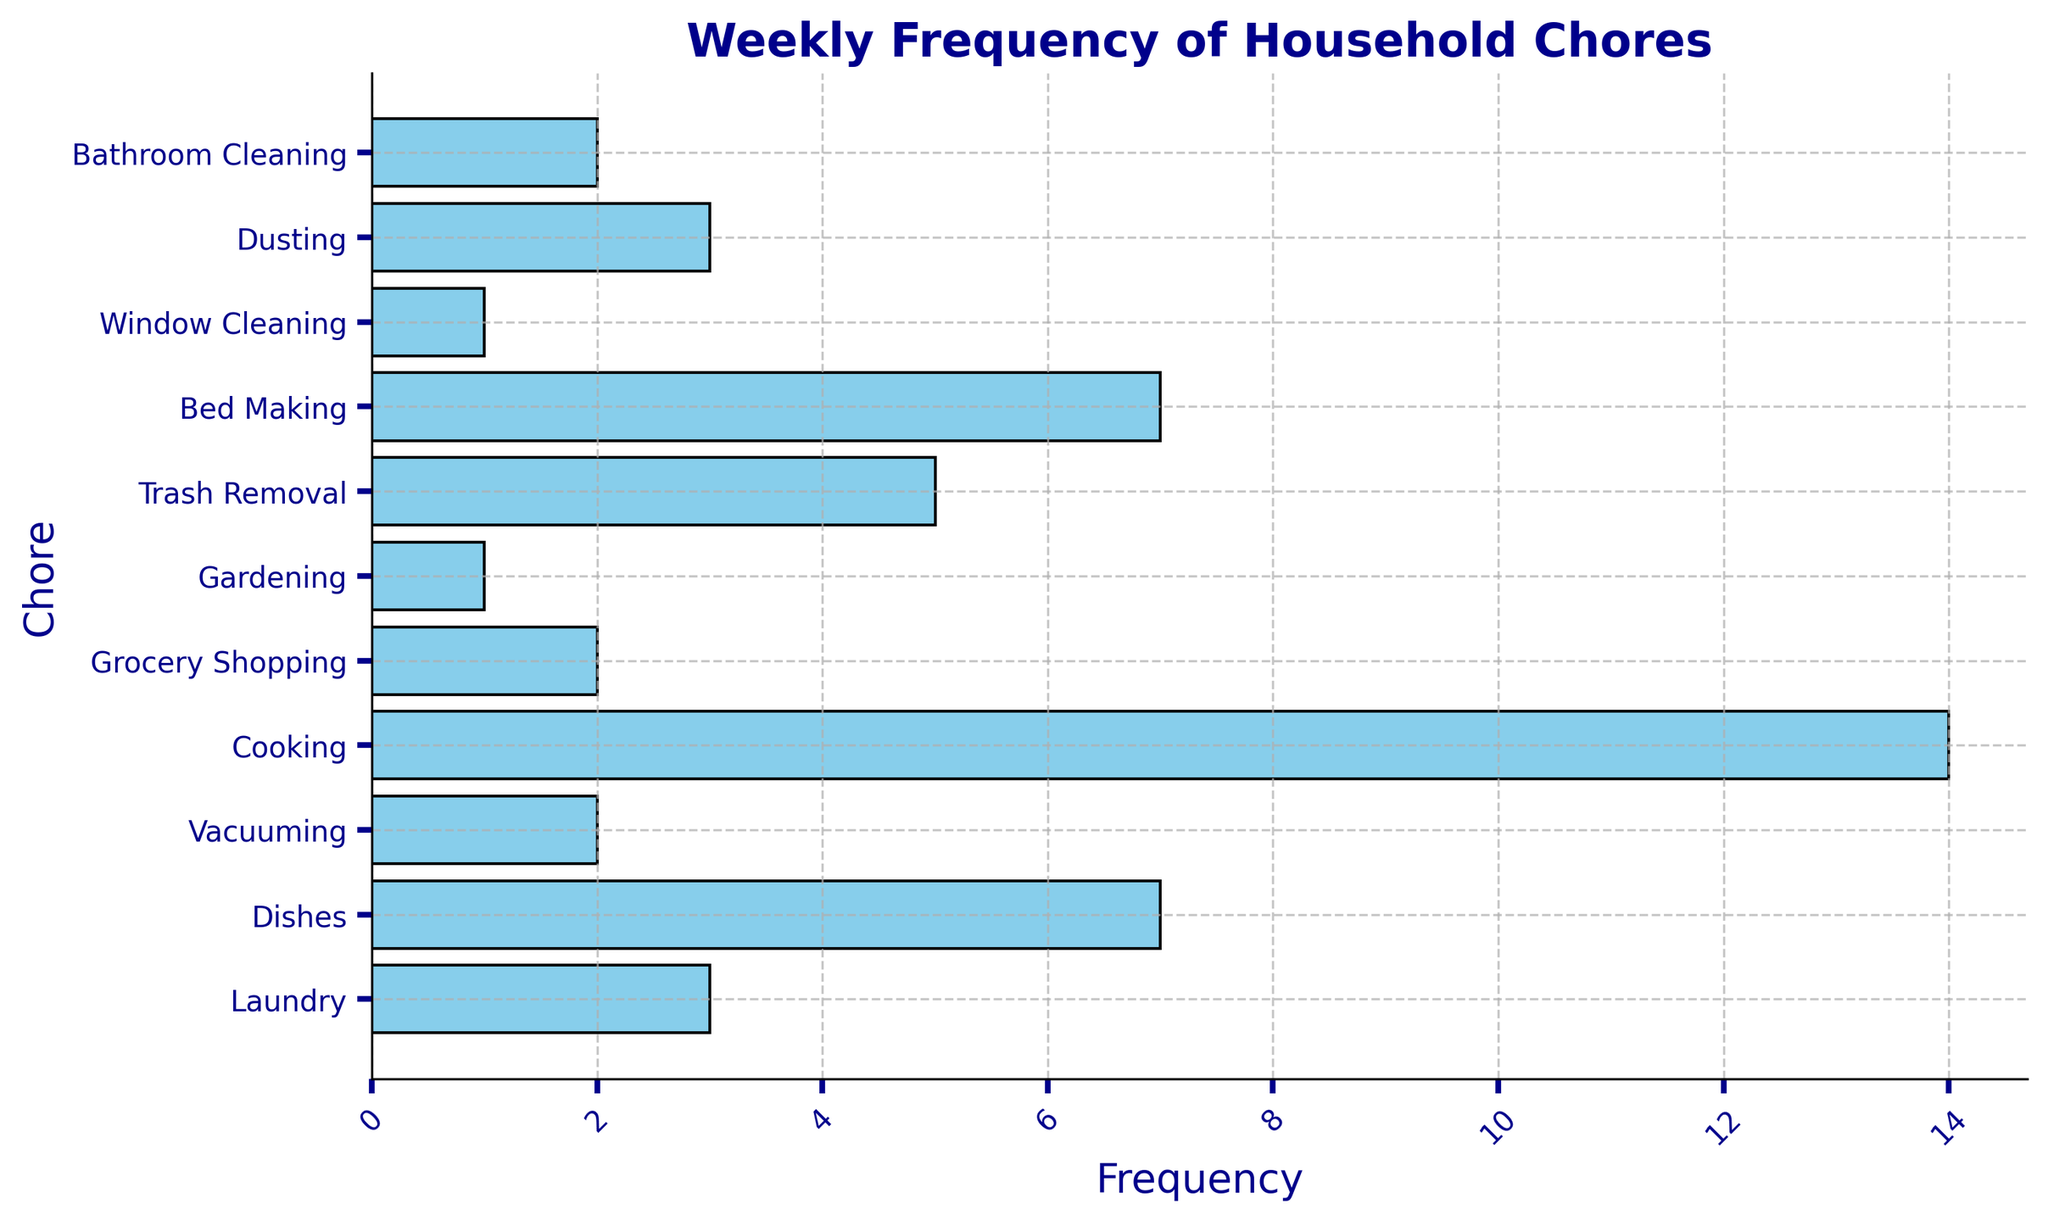What's the most frequently completed chore? The most frequently completed chore is the one with the highest bar. From the chart, Cooking has the highest frequency bar.
Answer: Cooking Which chore is done more often: Dusting or Vacuuming? By comparing the lengths of the bars for Dusting and Vacuuming, we see Dusting has a frequency of 3 whereas Vacuuming has a frequency of 2.
Answer: Dusting What is the combined frequency of Dishes and Trash Removal? To find the combined frequency, sum the frequencies of Dishes and Trash Removal. Dishes = 7 and Trash Removal = 5, so combined is 7 + 5.
Answer: 12 Which chores have the same frequency of completion and what is that frequency? By observing the bars, we note that Dishes and Bed Making both have a frequency of 7.
Answer: Dishes and Bed Making, 7 How many chores are completed less frequently than Trash Removal? Trash Removal has a frequency of 5. Count the number of bars with a frequency less than 5: Laundry (3), Vacuuming (2), Grocery Shopping (2), Gardening (1), Window Cleaning (1), Dusting (3), Bathroom Cleaning (2). There are 7 such chores.
Answer: 7 What is the average frequency of Grocery Shopping, Gardening, and Window Cleaning? Sum the frequencies of these chores and divide by the number of chores. Frequencies: Grocery Shopping = 2, Gardening = 1, Window Cleaning = 1. Sum = 2+1+1=4. Average = 4/3.
Answer: 1.33 Which chore is the second least frequently completed? The least frequent chores are Gardening and Window Cleaning both at 1. The next smallest frequency is 2. Vacuuming, Grocery Shopping, and Bathroom Cleaning all have this frequency.
Answer: Vacuuming, Grocery Shopping, and Bathroom Cleaning How does the frequency of Bed Making compare to that of Dusting? Bed Making has a frequency of 7 and Dusting has a frequency of 3. Bed Making is more frequent than Dusting.
Answer: Bed Making is more frequent Identify the chores completed exactly twice a week? By identifying the bars with a frequency of 2, we find Vacuuming, Grocery Shopping, and Bathroom Cleaning are completed twice a week.
Answer: Vacuuming, Grocery Shopping, Bathroom Cleaning What is the sum of frequencies for the top 3 chores? Identify the top 3 chores by frequency and sum. Cooking (14), Dishes (7), and Bed Making (7), so the sum is 14 + 7 + 7 = 28.
Answer: 28 